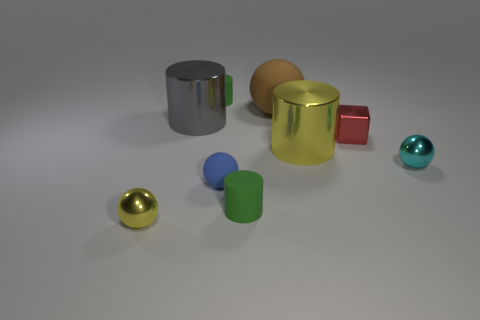There is a rubber cylinder that is behind the tiny ball on the right side of the blue rubber sphere; what is its color?
Provide a succinct answer. Green. Is the shape of the tiny yellow thing the same as the green rubber object that is behind the large matte ball?
Ensure brevity in your answer.  No. There is a yellow object that is on the right side of the yellow metallic thing left of the tiny green matte cylinder in front of the tiny cyan metal ball; what is its material?
Ensure brevity in your answer.  Metal. Are there any rubber objects of the same size as the yellow ball?
Your answer should be very brief. Yes. What size is the cyan ball that is the same material as the large yellow cylinder?
Make the answer very short. Small. There is a small red metallic object; what shape is it?
Make the answer very short. Cube. Do the cyan ball and the large cylinder that is on the left side of the large yellow object have the same material?
Offer a very short reply. Yes. How many objects are either tiny metallic balls or big green rubber cylinders?
Your response must be concise. 2. Is there a tiny green matte cube?
Your response must be concise. No. There is a yellow object to the left of the small rubber thing behind the cube; what shape is it?
Keep it short and to the point. Sphere. 